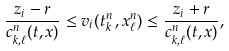<formula> <loc_0><loc_0><loc_500><loc_500>\frac { z _ { i } - r } { c ^ { n } _ { k , \ell } ( t , x ) } \leq v _ { i } ( t _ { k } ^ { n } \, , x ^ { n } _ { \ell } ) \leq \frac { z _ { i } + r } { c ^ { n } _ { k , \ell } ( t , x ) } ,</formula> 